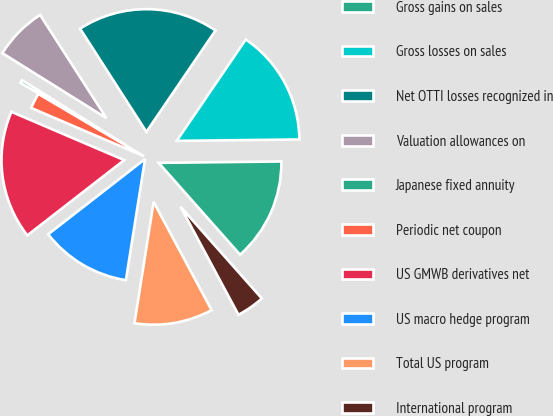Convert chart to OTSL. <chart><loc_0><loc_0><loc_500><loc_500><pie_chart><fcel>Gross gains on sales<fcel>Gross losses on sales<fcel>Net OTTI losses recognized in<fcel>Valuation allowances on<fcel>Japanese fixed annuity<fcel>Periodic net coupon<fcel>US GMWB derivatives net<fcel>US macro hedge program<fcel>Total US program<fcel>International program<nl><fcel>13.64%<fcel>15.3%<fcel>18.61%<fcel>7.02%<fcel>0.4%<fcel>2.05%<fcel>16.95%<fcel>11.99%<fcel>10.33%<fcel>3.71%<nl></chart> 